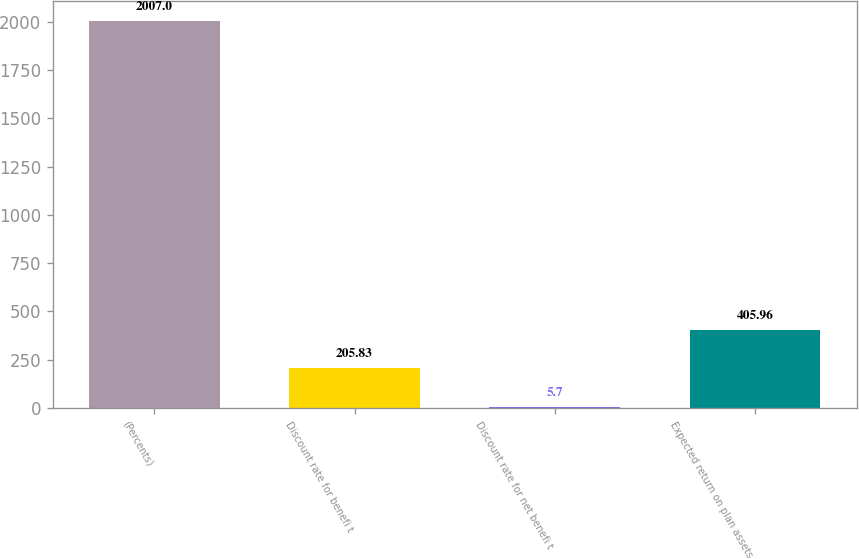Convert chart. <chart><loc_0><loc_0><loc_500><loc_500><bar_chart><fcel>(Percents)<fcel>Discount rate for benefi t<fcel>Discount rate for net benefi t<fcel>Expected return on plan assets<nl><fcel>2007<fcel>205.83<fcel>5.7<fcel>405.96<nl></chart> 